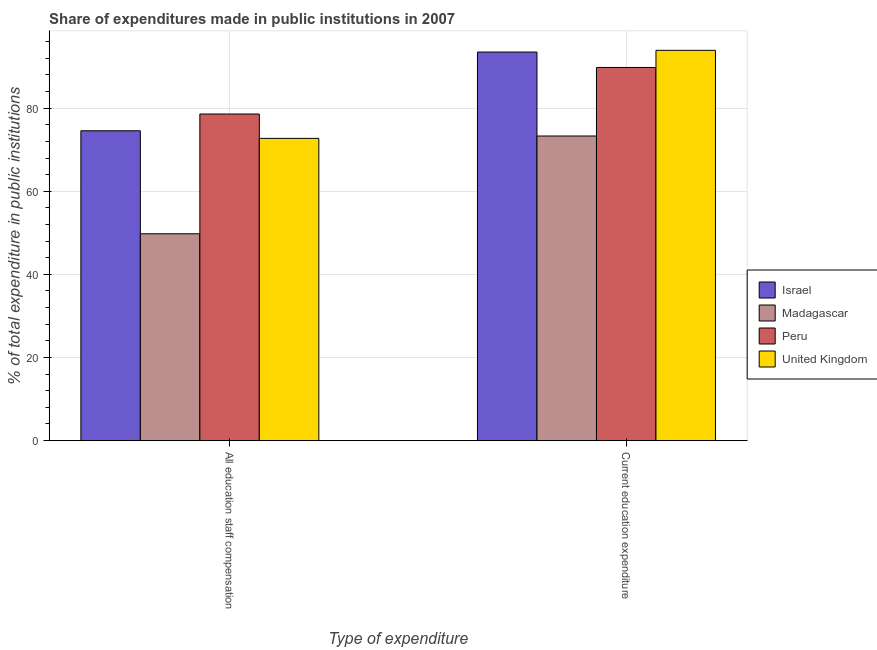Are the number of bars per tick equal to the number of legend labels?
Offer a terse response. Yes. How many bars are there on the 2nd tick from the left?
Provide a succinct answer. 4. What is the label of the 1st group of bars from the left?
Your answer should be very brief. All education staff compensation. What is the expenditure in education in Madagascar?
Make the answer very short. 73.3. Across all countries, what is the maximum expenditure in staff compensation?
Your answer should be very brief. 78.6. Across all countries, what is the minimum expenditure in staff compensation?
Keep it short and to the point. 49.77. In which country was the expenditure in education minimum?
Offer a very short reply. Madagascar. What is the total expenditure in education in the graph?
Offer a terse response. 350.52. What is the difference between the expenditure in education in United Kingdom and that in Israel?
Give a very brief answer. 0.41. What is the difference between the expenditure in staff compensation in Madagascar and the expenditure in education in Peru?
Provide a short and direct response. -40.02. What is the average expenditure in education per country?
Provide a short and direct response. 87.63. What is the difference between the expenditure in education and expenditure in staff compensation in Peru?
Make the answer very short. 11.2. What is the ratio of the expenditure in education in United Kingdom to that in Peru?
Offer a terse response. 1.05. Is the expenditure in staff compensation in United Kingdom less than that in Madagascar?
Your answer should be very brief. No. What does the 1st bar from the left in All education staff compensation represents?
Your answer should be very brief. Israel. What does the 4th bar from the right in Current education expenditure represents?
Offer a terse response. Israel. How many countries are there in the graph?
Give a very brief answer. 4. What is the difference between two consecutive major ticks on the Y-axis?
Provide a succinct answer. 20. How are the legend labels stacked?
Provide a succinct answer. Vertical. What is the title of the graph?
Your response must be concise. Share of expenditures made in public institutions in 2007. Does "Belarus" appear as one of the legend labels in the graph?
Your answer should be compact. No. What is the label or title of the X-axis?
Ensure brevity in your answer.  Type of expenditure. What is the label or title of the Y-axis?
Your response must be concise. % of total expenditure in public institutions. What is the % of total expenditure in public institutions in Israel in All education staff compensation?
Offer a very short reply. 74.56. What is the % of total expenditure in public institutions of Madagascar in All education staff compensation?
Your answer should be compact. 49.77. What is the % of total expenditure in public institutions in Peru in All education staff compensation?
Give a very brief answer. 78.6. What is the % of total expenditure in public institutions of United Kingdom in All education staff compensation?
Your answer should be compact. 72.73. What is the % of total expenditure in public institutions of Israel in Current education expenditure?
Your answer should be compact. 93.51. What is the % of total expenditure in public institutions of Madagascar in Current education expenditure?
Provide a short and direct response. 73.3. What is the % of total expenditure in public institutions in Peru in Current education expenditure?
Make the answer very short. 89.79. What is the % of total expenditure in public institutions in United Kingdom in Current education expenditure?
Give a very brief answer. 93.92. Across all Type of expenditure, what is the maximum % of total expenditure in public institutions of Israel?
Offer a terse response. 93.51. Across all Type of expenditure, what is the maximum % of total expenditure in public institutions in Madagascar?
Make the answer very short. 73.3. Across all Type of expenditure, what is the maximum % of total expenditure in public institutions of Peru?
Offer a very short reply. 89.79. Across all Type of expenditure, what is the maximum % of total expenditure in public institutions in United Kingdom?
Offer a very short reply. 93.92. Across all Type of expenditure, what is the minimum % of total expenditure in public institutions of Israel?
Your answer should be compact. 74.56. Across all Type of expenditure, what is the minimum % of total expenditure in public institutions in Madagascar?
Keep it short and to the point. 49.77. Across all Type of expenditure, what is the minimum % of total expenditure in public institutions in Peru?
Make the answer very short. 78.6. Across all Type of expenditure, what is the minimum % of total expenditure in public institutions of United Kingdom?
Your answer should be very brief. 72.73. What is the total % of total expenditure in public institutions in Israel in the graph?
Keep it short and to the point. 168.07. What is the total % of total expenditure in public institutions in Madagascar in the graph?
Ensure brevity in your answer.  123.07. What is the total % of total expenditure in public institutions of Peru in the graph?
Give a very brief answer. 168.39. What is the total % of total expenditure in public institutions in United Kingdom in the graph?
Offer a terse response. 166.65. What is the difference between the % of total expenditure in public institutions of Israel in All education staff compensation and that in Current education expenditure?
Provide a short and direct response. -18.95. What is the difference between the % of total expenditure in public institutions in Madagascar in All education staff compensation and that in Current education expenditure?
Provide a short and direct response. -23.53. What is the difference between the % of total expenditure in public institutions in Peru in All education staff compensation and that in Current education expenditure?
Ensure brevity in your answer.  -11.2. What is the difference between the % of total expenditure in public institutions of United Kingdom in All education staff compensation and that in Current education expenditure?
Ensure brevity in your answer.  -21.18. What is the difference between the % of total expenditure in public institutions of Israel in All education staff compensation and the % of total expenditure in public institutions of Madagascar in Current education expenditure?
Ensure brevity in your answer.  1.26. What is the difference between the % of total expenditure in public institutions in Israel in All education staff compensation and the % of total expenditure in public institutions in Peru in Current education expenditure?
Provide a succinct answer. -15.23. What is the difference between the % of total expenditure in public institutions of Israel in All education staff compensation and the % of total expenditure in public institutions of United Kingdom in Current education expenditure?
Offer a very short reply. -19.36. What is the difference between the % of total expenditure in public institutions of Madagascar in All education staff compensation and the % of total expenditure in public institutions of Peru in Current education expenditure?
Make the answer very short. -40.02. What is the difference between the % of total expenditure in public institutions in Madagascar in All education staff compensation and the % of total expenditure in public institutions in United Kingdom in Current education expenditure?
Provide a short and direct response. -44.15. What is the difference between the % of total expenditure in public institutions in Peru in All education staff compensation and the % of total expenditure in public institutions in United Kingdom in Current education expenditure?
Your answer should be compact. -15.32. What is the average % of total expenditure in public institutions of Israel per Type of expenditure?
Your response must be concise. 84.03. What is the average % of total expenditure in public institutions in Madagascar per Type of expenditure?
Provide a short and direct response. 61.54. What is the average % of total expenditure in public institutions in Peru per Type of expenditure?
Your response must be concise. 84.19. What is the average % of total expenditure in public institutions of United Kingdom per Type of expenditure?
Your answer should be compact. 83.33. What is the difference between the % of total expenditure in public institutions of Israel and % of total expenditure in public institutions of Madagascar in All education staff compensation?
Offer a very short reply. 24.79. What is the difference between the % of total expenditure in public institutions in Israel and % of total expenditure in public institutions in Peru in All education staff compensation?
Ensure brevity in your answer.  -4.03. What is the difference between the % of total expenditure in public institutions of Israel and % of total expenditure in public institutions of United Kingdom in All education staff compensation?
Offer a terse response. 1.83. What is the difference between the % of total expenditure in public institutions of Madagascar and % of total expenditure in public institutions of Peru in All education staff compensation?
Provide a short and direct response. -28.82. What is the difference between the % of total expenditure in public institutions in Madagascar and % of total expenditure in public institutions in United Kingdom in All education staff compensation?
Offer a terse response. -22.96. What is the difference between the % of total expenditure in public institutions of Peru and % of total expenditure in public institutions of United Kingdom in All education staff compensation?
Ensure brevity in your answer.  5.86. What is the difference between the % of total expenditure in public institutions in Israel and % of total expenditure in public institutions in Madagascar in Current education expenditure?
Ensure brevity in your answer.  20.21. What is the difference between the % of total expenditure in public institutions of Israel and % of total expenditure in public institutions of Peru in Current education expenditure?
Your response must be concise. 3.72. What is the difference between the % of total expenditure in public institutions of Israel and % of total expenditure in public institutions of United Kingdom in Current education expenditure?
Your answer should be compact. -0.41. What is the difference between the % of total expenditure in public institutions in Madagascar and % of total expenditure in public institutions in Peru in Current education expenditure?
Your answer should be compact. -16.49. What is the difference between the % of total expenditure in public institutions in Madagascar and % of total expenditure in public institutions in United Kingdom in Current education expenditure?
Provide a succinct answer. -20.62. What is the difference between the % of total expenditure in public institutions of Peru and % of total expenditure in public institutions of United Kingdom in Current education expenditure?
Your answer should be very brief. -4.13. What is the ratio of the % of total expenditure in public institutions of Israel in All education staff compensation to that in Current education expenditure?
Make the answer very short. 0.8. What is the ratio of the % of total expenditure in public institutions in Madagascar in All education staff compensation to that in Current education expenditure?
Make the answer very short. 0.68. What is the ratio of the % of total expenditure in public institutions of Peru in All education staff compensation to that in Current education expenditure?
Keep it short and to the point. 0.88. What is the ratio of the % of total expenditure in public institutions in United Kingdom in All education staff compensation to that in Current education expenditure?
Your answer should be compact. 0.77. What is the difference between the highest and the second highest % of total expenditure in public institutions of Israel?
Offer a very short reply. 18.95. What is the difference between the highest and the second highest % of total expenditure in public institutions of Madagascar?
Your answer should be very brief. 23.53. What is the difference between the highest and the second highest % of total expenditure in public institutions in Peru?
Offer a terse response. 11.2. What is the difference between the highest and the second highest % of total expenditure in public institutions in United Kingdom?
Make the answer very short. 21.18. What is the difference between the highest and the lowest % of total expenditure in public institutions of Israel?
Offer a very short reply. 18.95. What is the difference between the highest and the lowest % of total expenditure in public institutions in Madagascar?
Give a very brief answer. 23.53. What is the difference between the highest and the lowest % of total expenditure in public institutions in Peru?
Your answer should be compact. 11.2. What is the difference between the highest and the lowest % of total expenditure in public institutions in United Kingdom?
Give a very brief answer. 21.18. 